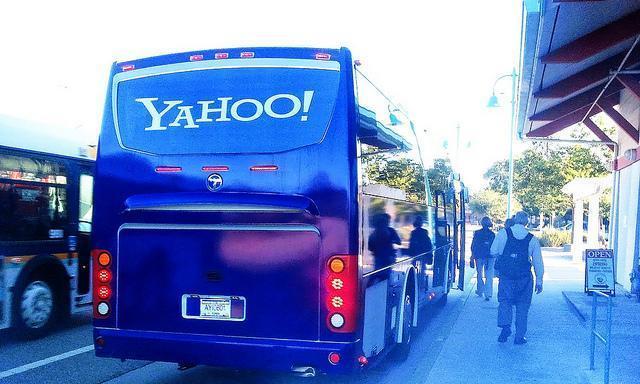How many buses are in this picture?
Give a very brief answer. 2. How many buses are there?
Give a very brief answer. 2. How many cakes are on the table?
Give a very brief answer. 0. 